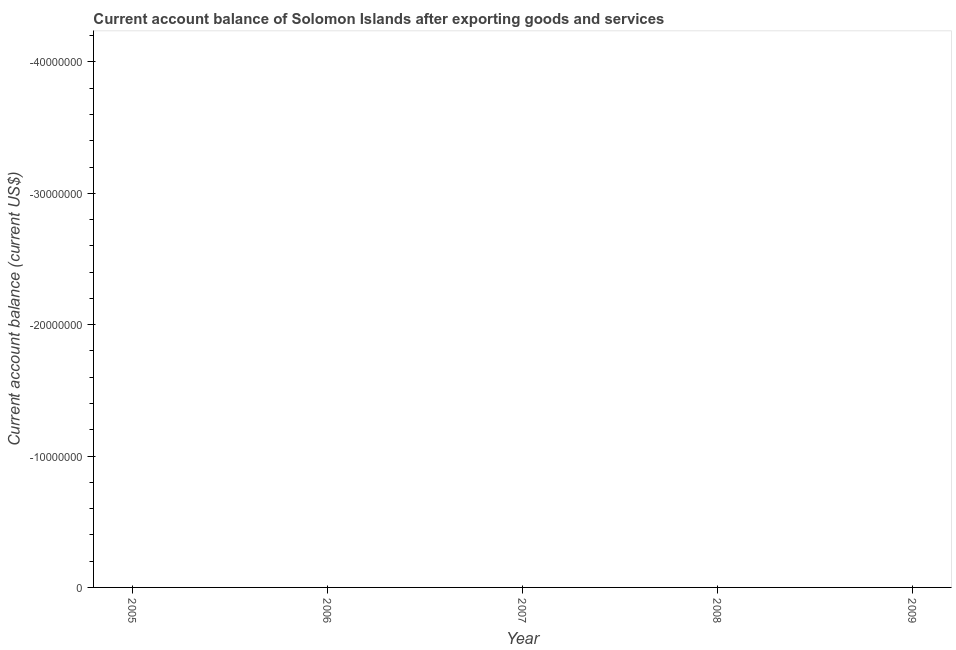What is the current account balance in 2008?
Make the answer very short. 0. What is the sum of the current account balance?
Make the answer very short. 0. What is the median current account balance?
Your answer should be compact. 0. In how many years, is the current account balance greater than the average current account balance taken over all years?
Make the answer very short. 0. What is the difference between two consecutive major ticks on the Y-axis?
Offer a terse response. 1.00e+07. Does the graph contain grids?
Make the answer very short. No. What is the title of the graph?
Offer a very short reply. Current account balance of Solomon Islands after exporting goods and services. What is the label or title of the X-axis?
Provide a succinct answer. Year. What is the label or title of the Y-axis?
Provide a succinct answer. Current account balance (current US$). What is the Current account balance (current US$) in 2006?
Make the answer very short. 0. What is the Current account balance (current US$) of 2007?
Your answer should be very brief. 0. What is the Current account balance (current US$) in 2009?
Your answer should be compact. 0. 